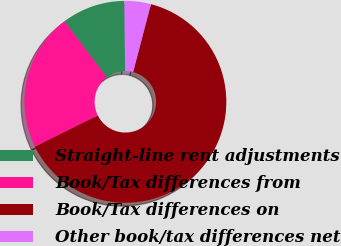<chart> <loc_0><loc_0><loc_500><loc_500><pie_chart><fcel>Straight-line rent adjustments<fcel>Book/Tax differences from<fcel>Book/Tax differences on<fcel>Other book/tax differences net<nl><fcel>10.16%<fcel>22.03%<fcel>63.58%<fcel>4.23%<nl></chart> 